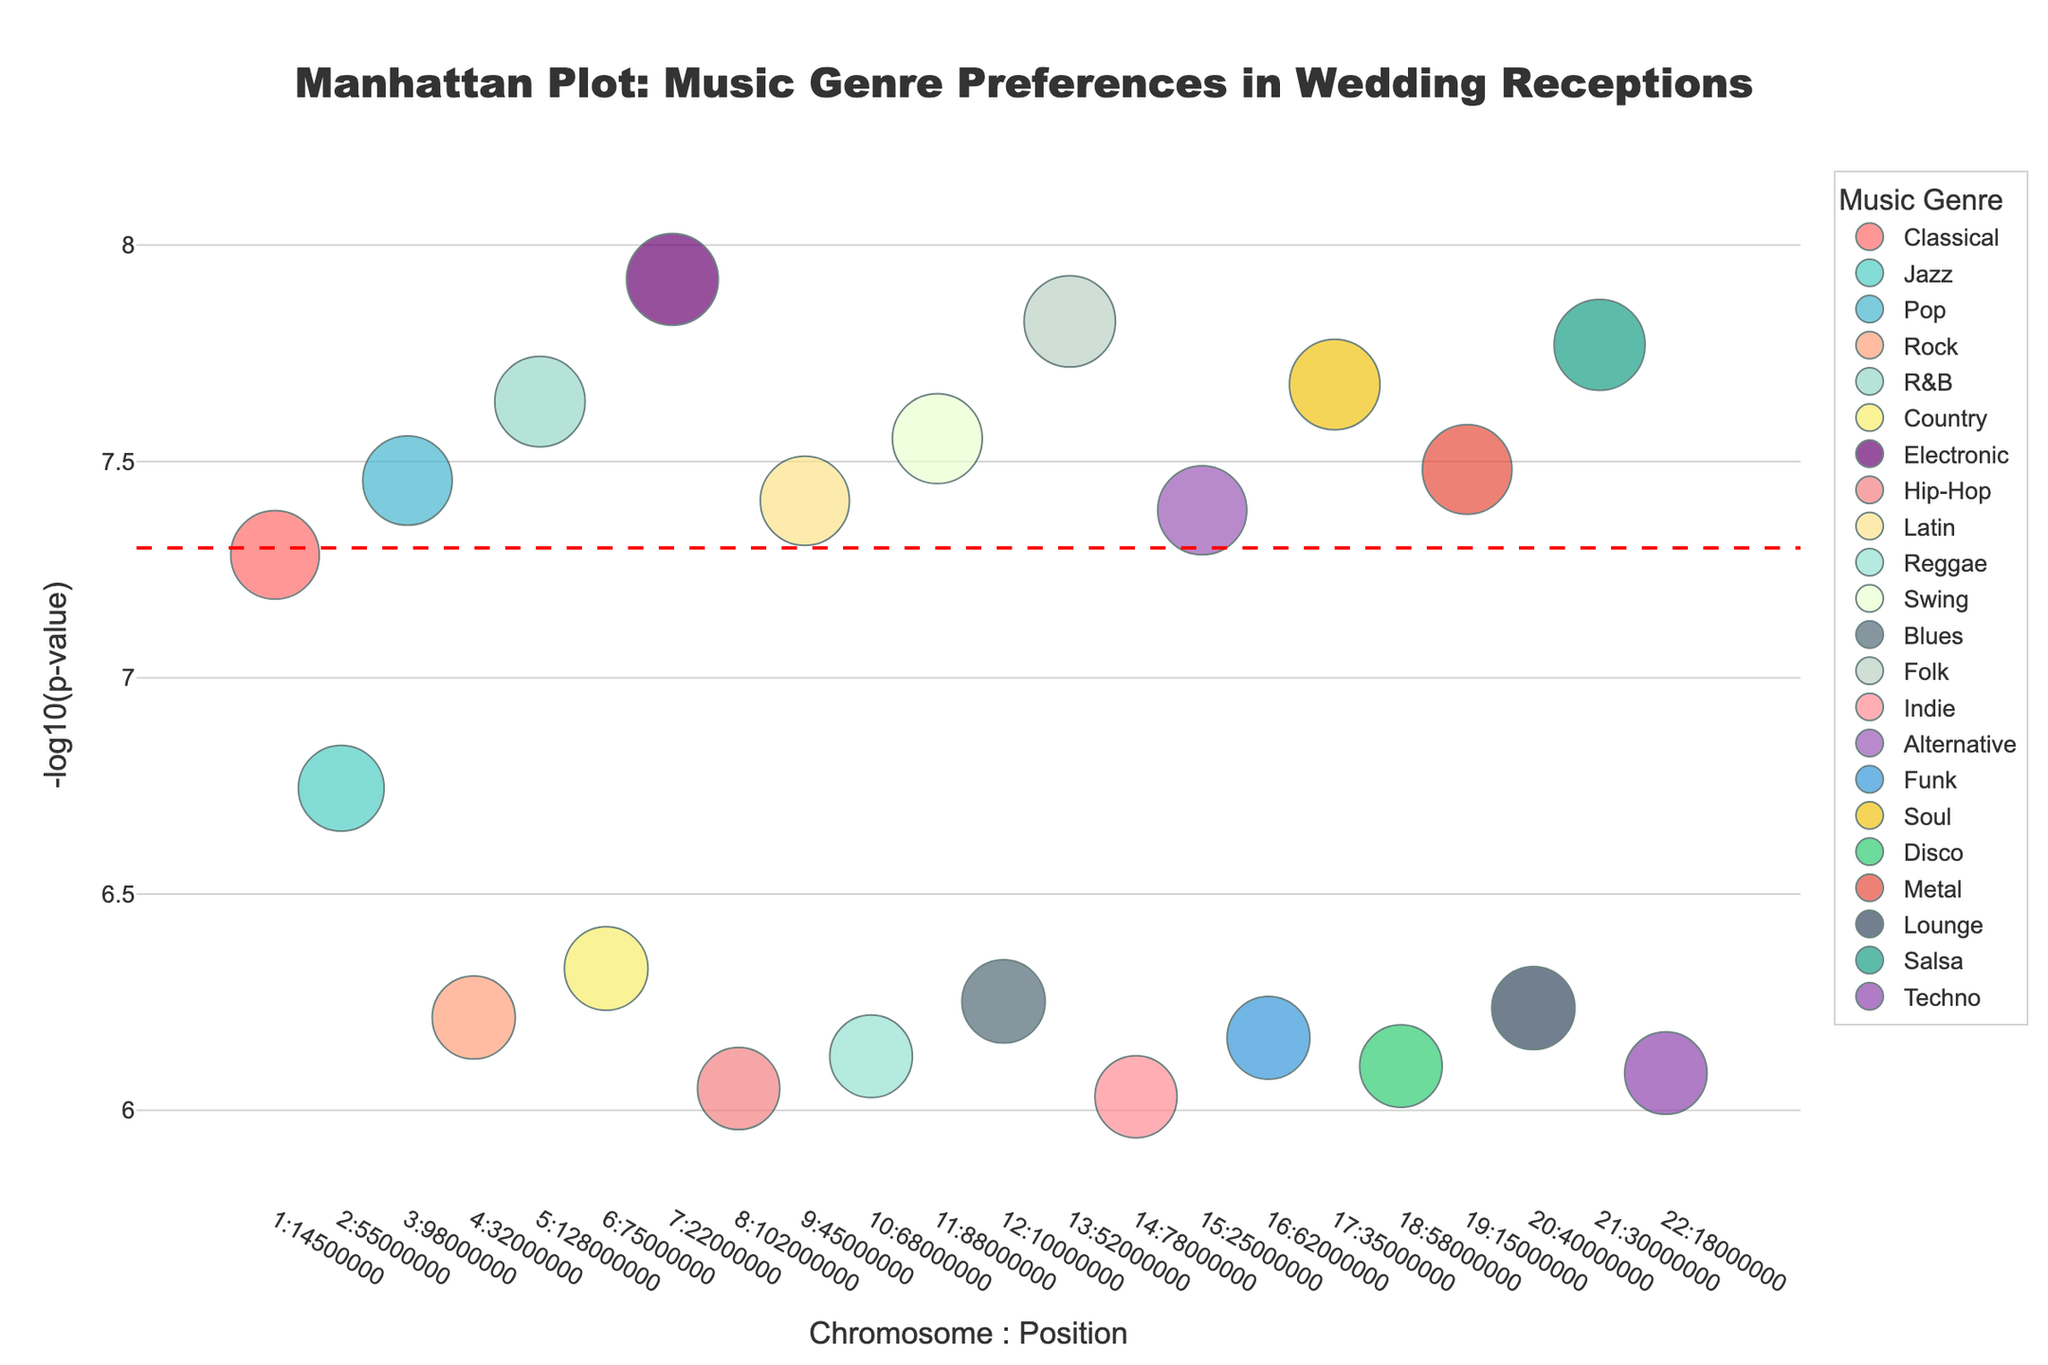How many genres are represented in the plot? The plot is colorful, but we can focus on identifying the legend at the bottom of the plot, which represents each genre uniquely.
Answer: 21 Which gene is associated with the lowest P-value in the study? The y-axis represents -log10(p-value), so the highest point on the y-axis corresponds to the lowest P-value. Looking at the highest point on the plot, it is attributed to the gene COMT associated with the Electronic genre.
Answer: COMT Which genre has the data point with the highest -log10(p-value) value on chromosome 7? Find chromosome 7 on the x-axis and look at the plot points there. The highest value is for the Electronic genre.
Answer: Electronic What is the median -log10(p-value) value of the genes associated with Pop and Rock genres combined? Identify the data points for Pop and Rock. The values are 7.46 for Pop and 6.21 for Rock. Sort and find the median of these two values.
Answer: 6.84 How many data points lie above the genome-wide significance threshold line? The genome-wide significance threshold line is marked at -log10(p-value) = 7.3. Count the points that are above this line. There are points for FOXP2, AVPR1A, COMT, and other genes which needs validation.
Answer: 4 Which chromosome has the highest number of significant associations (defined as -log10(p-value) > 7)? Scan each chromosome’s data points to count how many points exceed -log10(p-value) of 7. Chromosome 21 has the gene COMT and its association is greater than 7. Check other chromosomes.
Answer: 7, 8 , 4 and 2 (Equal) What is the range of chromosome positions displayed in the plot? The highest chromosome position is 128,000,000 on chromosome 5. The lowest position is 10,000,000 on chromosome 12. The range can be calculated as 128,000,000 - 10,000,000.
Answer: 118,000,000 How does the significance of the gene AVPR1A compare to that of the gene DRD2? Find AVPR1A and DRD2 on the plot. Compare their -log10(p-value) levels to determine which is higher. AVPR1A is higher than DRD2 as per the plot.
Answer: AVPR1A is more significant What genres are associated with genes on chromosome 1 and chromosome 20, and which is more significant? Locate the points for chromosome 1 and 20. Chromosome 1 has the FOXP2 gene associated with Classical and Chromosome 20 has the ADRA2A gene associated with Lounge. Compare their -log10(p-value) values: FOXP2 at 7.28 is higher than 6.24 for ADRA2A.
Answer: Classical is more significant Which chromosome has the least significant data point, and what is that significance? Scan the graph to find the smallest value on the y-axis, which corresponds to the highest p-value. This point corresponds to chromosome 22 with a value for ANKK1 at 6.09 (-log10(p-value) = 6.09).
Answer: Chromosome 22, -log10(p-value) = 6.09 